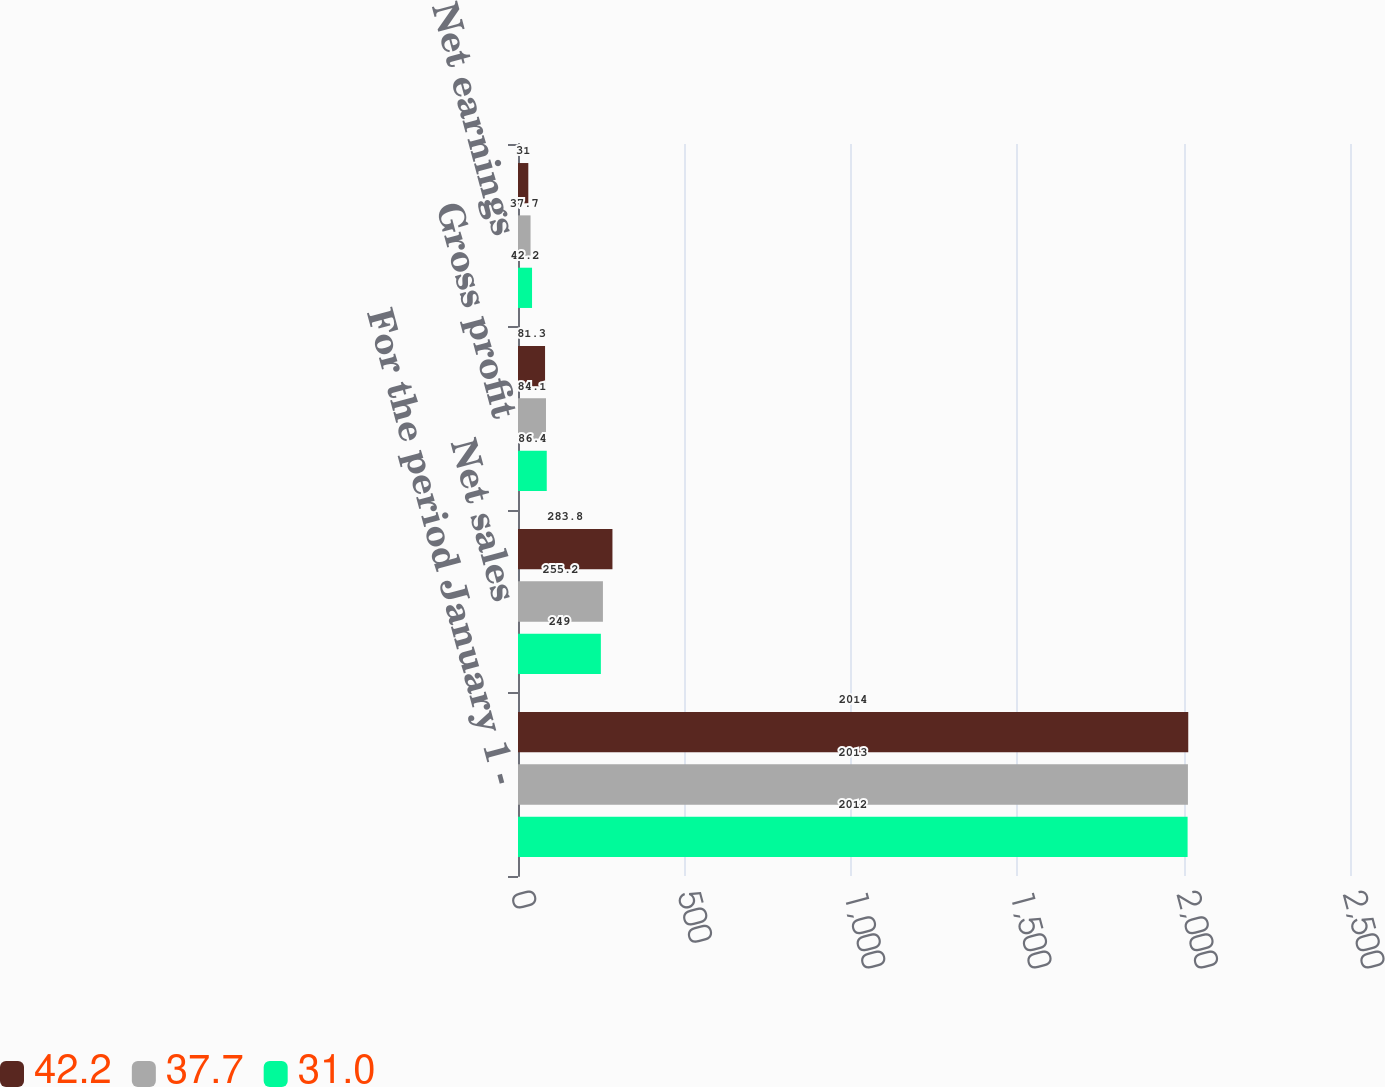<chart> <loc_0><loc_0><loc_500><loc_500><stacked_bar_chart><ecel><fcel>For the period January 1 -<fcel>Net sales<fcel>Gross profit<fcel>Net earnings<nl><fcel>42.2<fcel>2014<fcel>283.8<fcel>81.3<fcel>31<nl><fcel>37.7<fcel>2013<fcel>255.2<fcel>84.1<fcel>37.7<nl><fcel>31<fcel>2012<fcel>249<fcel>86.4<fcel>42.2<nl></chart> 